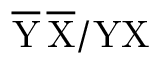Convert formula to latex. <formula><loc_0><loc_0><loc_500><loc_500>\overline { Y } \, \overline { X } / Y X</formula> 